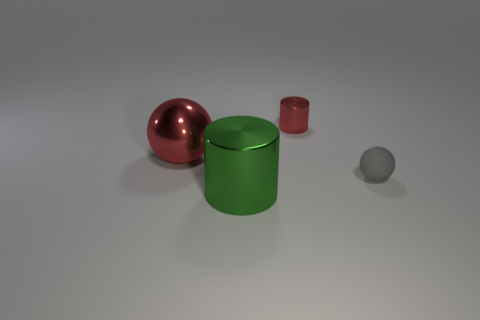Are there any other things that are made of the same material as the tiny ball?
Give a very brief answer. No. There is a sphere right of the small metallic cylinder; does it have the same color as the shiny cylinder that is in front of the red shiny cylinder?
Your answer should be compact. No. There is a red metal ball; what number of tiny shiny things are behind it?
Offer a very short reply. 1. Is there a green shiny cylinder to the right of the sphere that is on the right side of the shiny cylinder on the left side of the small red shiny thing?
Offer a terse response. No. How many cylinders are the same size as the gray matte object?
Your answer should be compact. 1. What is the sphere that is in front of the sphere behind the small gray ball made of?
Provide a short and direct response. Rubber. What shape is the small object in front of the red object to the left of the metallic cylinder behind the large cylinder?
Give a very brief answer. Sphere. Is the shape of the metallic object on the right side of the green metallic cylinder the same as the thing that is on the left side of the large green cylinder?
Your answer should be compact. No. What number of other things are made of the same material as the small gray object?
Offer a very short reply. 0. What is the shape of the green object that is made of the same material as the big red thing?
Offer a very short reply. Cylinder. 